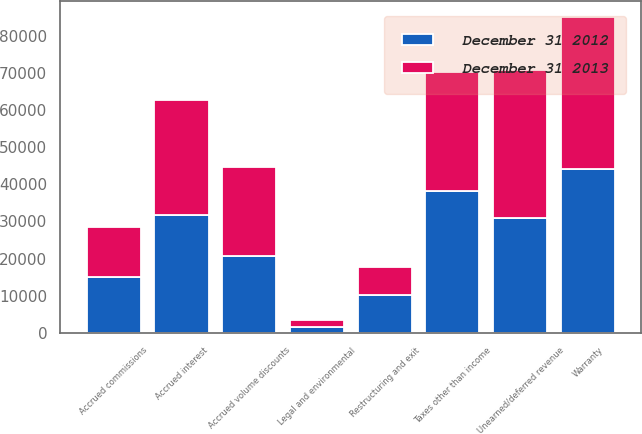<chart> <loc_0><loc_0><loc_500><loc_500><stacked_bar_chart><ecel><fcel>Warranty<fcel>Unearned/deferred revenue<fcel>Taxes other than income<fcel>Accrued interest<fcel>Accrued volume discounts<fcel>Accrued commissions<fcel>Restructuring and exit<fcel>Legal and environmental<nl><fcel>December 31 2012<fcel>44228<fcel>30817<fcel>38232<fcel>31738<fcel>20576<fcel>15087<fcel>10046<fcel>1623<nl><fcel>December 31 2013<fcel>41069<fcel>39941<fcel>32099<fcel>30972<fcel>24114<fcel>13550<fcel>7665<fcel>1873<nl></chart> 